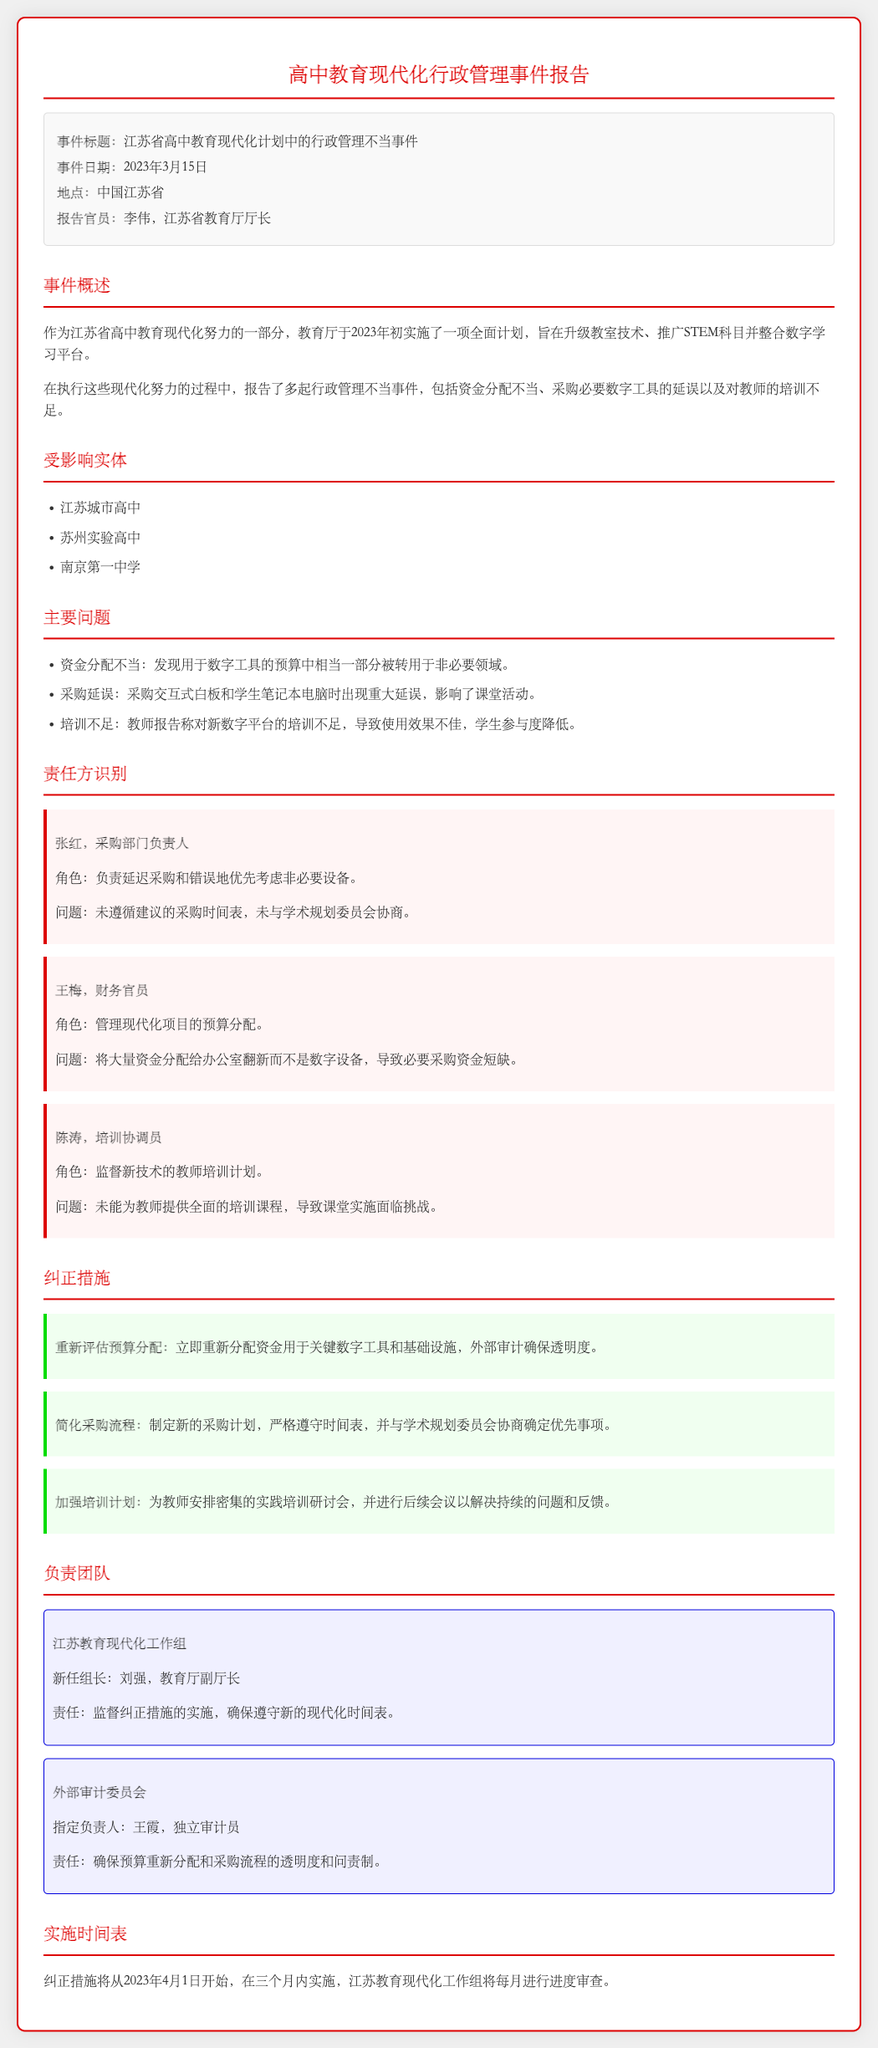事件标题是什么？ 事件标题是在报告的元数据部分，第一个项目中清楚列出。
Answer: 江苏省高中教育现代化计划中的行政管理不当事件 事件发生在哪一天？ 事件日期是在报告的元数据部分的第二个项目中指定的。
Answer: 2023年3月15日 谁是报告的官员？ 报告官员的姓名显示在事件概述的元数据部分。
Answer: 李伟，江苏省教育厅厅长 主要问题有哪些？ 主要问题列在报告的相应部分，包含几个具体问题。
Answer: 资金分配不当、采购延误、培训不足 谁负责采购部门的管理？ 责任方识别部分列出了具体责任人的姓名和角色。
Answer: 张红，采购部门负责人 纠正措施的实施开始时间是什么时候？ 实施时间表部分指明了纠正措施的开始时间。
Answer: 2023年4月1日 新任组长是谁？ 负责团队部分中提到的新任组长的姓名。
Answer: 刘强，教育厅副厅长 采购过程中出现了什么问题？ 主要问题部分详细说明了采购过程中遇到的问题。
Answer: 采购延误 外部审计委员会负责人是谁？ 负责团队部分给出了外部审计委员会负责人的姓名。
Answer: 王霞，独立审计员 